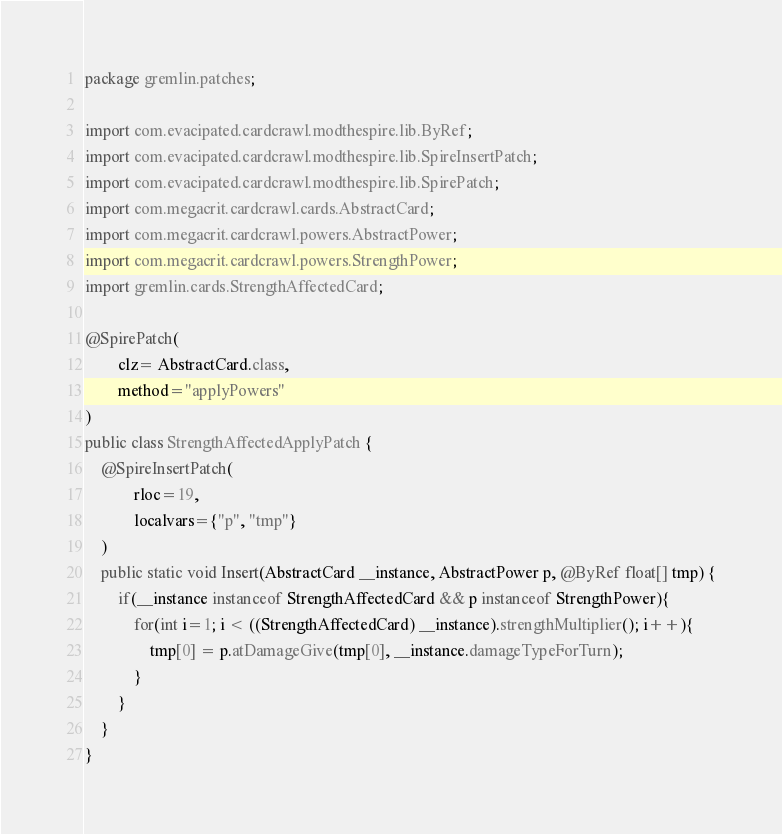Convert code to text. <code><loc_0><loc_0><loc_500><loc_500><_Java_>package gremlin.patches;

import com.evacipated.cardcrawl.modthespire.lib.ByRef;
import com.evacipated.cardcrawl.modthespire.lib.SpireInsertPatch;
import com.evacipated.cardcrawl.modthespire.lib.SpirePatch;
import com.megacrit.cardcrawl.cards.AbstractCard;
import com.megacrit.cardcrawl.powers.AbstractPower;
import com.megacrit.cardcrawl.powers.StrengthPower;
import gremlin.cards.StrengthAffectedCard;

@SpirePatch(
        clz= AbstractCard.class,
        method="applyPowers"
)
public class StrengthAffectedApplyPatch {
    @SpireInsertPatch(
            rloc=19,
            localvars={"p", "tmp"}
    )
    public static void Insert(AbstractCard __instance, AbstractPower p, @ByRef float[] tmp) {
        if(__instance instanceof StrengthAffectedCard && p instanceof StrengthPower){
            for(int i=1; i < ((StrengthAffectedCard) __instance).strengthMultiplier(); i++){
                tmp[0] = p.atDamageGive(tmp[0], __instance.damageTypeForTurn);
            }
        }
    }
}

</code> 